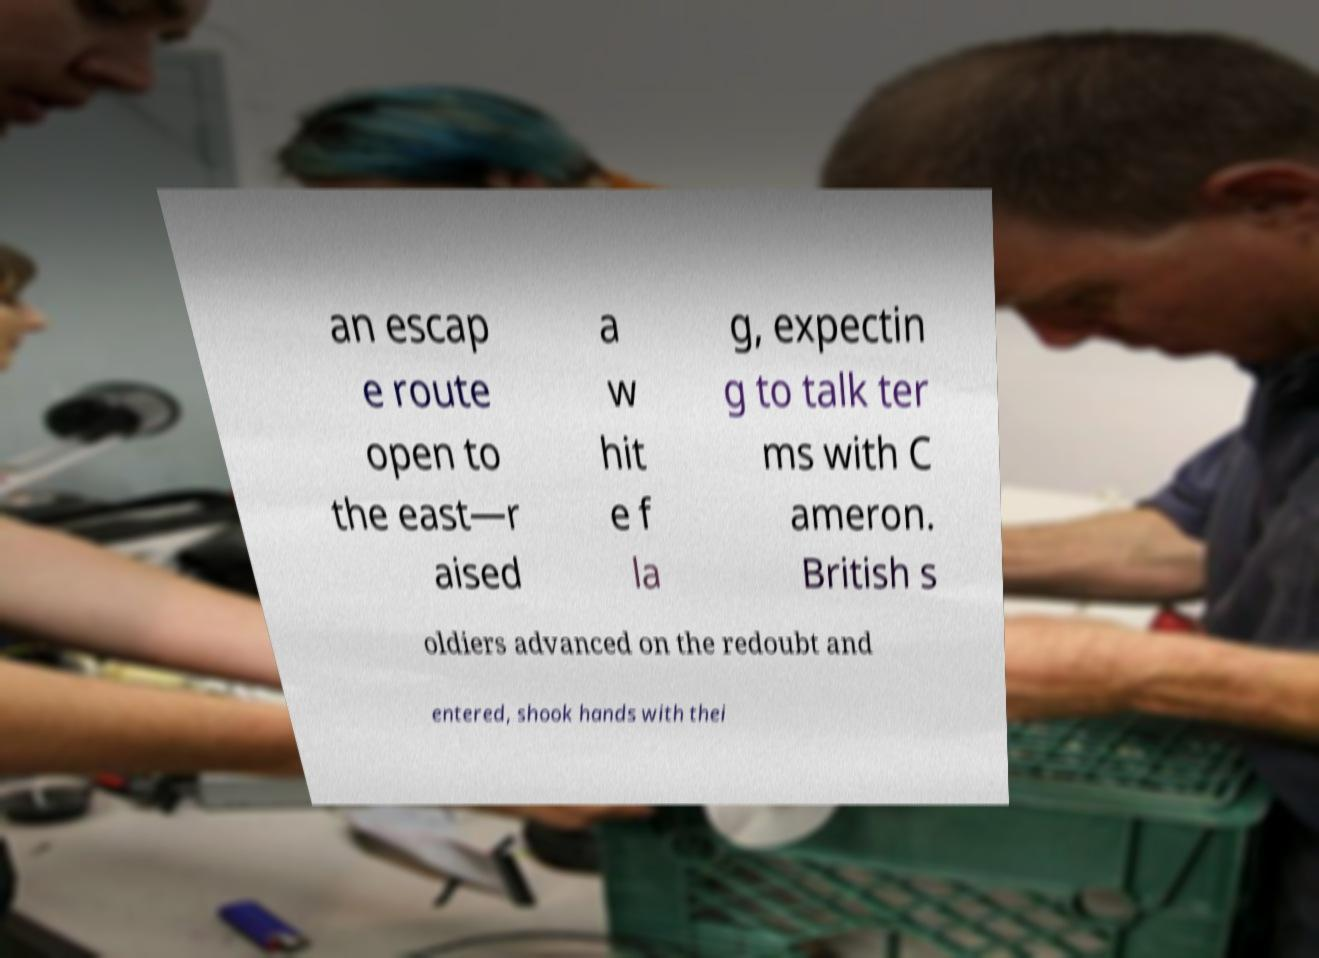Please read and relay the text visible in this image. What does it say? an escap e route open to the east—r aised a w hit e f la g, expectin g to talk ter ms with C ameron. British s oldiers advanced on the redoubt and entered, shook hands with thei 